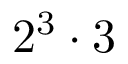Convert formula to latex. <formula><loc_0><loc_0><loc_500><loc_500>2 ^ { 3 } \cdot 3</formula> 